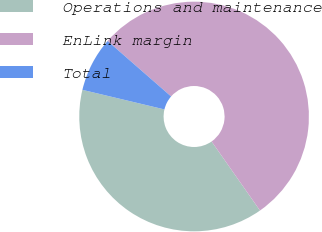Convert chart. <chart><loc_0><loc_0><loc_500><loc_500><pie_chart><fcel>Operations and maintenance<fcel>EnLink margin<fcel>Total<nl><fcel>38.46%<fcel>53.85%<fcel>7.69%<nl></chart> 